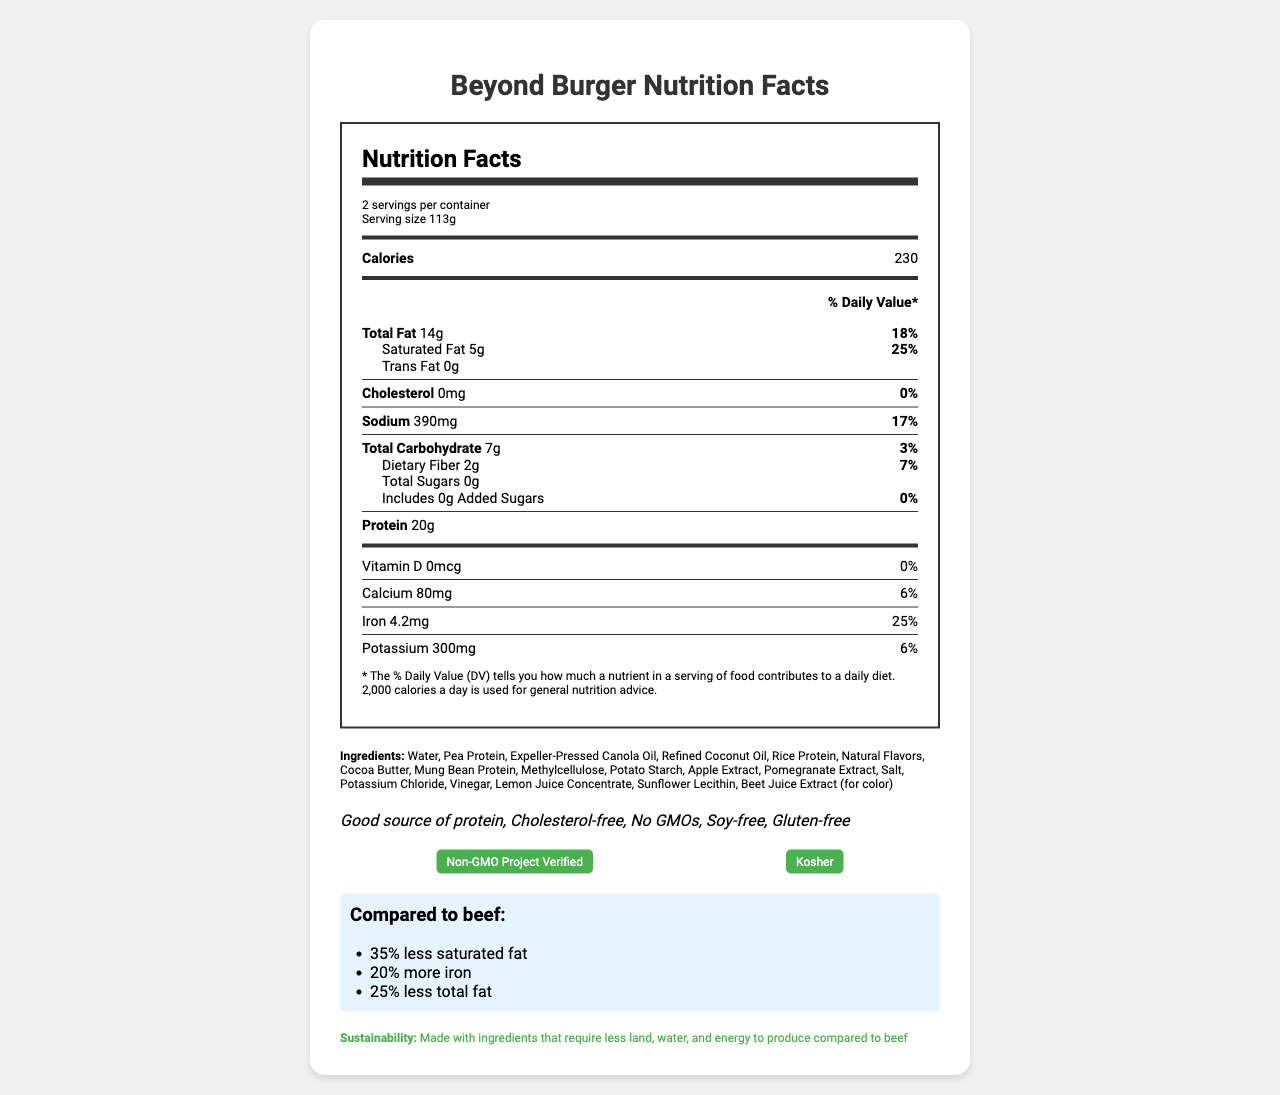How many servings are in a container of Beyond Burger? The label states "2 servings per container".
Answer: 2 What is the serving size of Beyond Burger? The label specifies the serving size as 113 grams.
Answer: 113g What is the total calorie count per serving for Beyond Burger? The label indicates that each serving contains 230 calories.
Answer: 230 calories How much protein is in each serving? The label lists that each serving has 20 grams of protein.
Answer: 20g How much total fat does one serving contain? The label mentions "Total Fat 14g".
Answer: 14g What percentage of daily value of iron does Beyond Burger provide? A. 10% B. 25% C. 50% The label indicates "Iron 25%".
Answer: B. 25% Which ingredient is used for coloring in Beyond Burger? A. Cocoa Butter B. Beet Juice Extract C. Sunflower Lecithin Beet Juice Extract is used for color, as listed in the ingredients.
Answer: B. Beet Juice Extract Is Beyond Burger gluten-free? The health claims mention that the product is gluten-free.
Answer: Yes Does Beyond Burger contain any cholesterol? The label states "Cholesterol 0mg" and "0% daily value".
Answer: No Summarize the nutritional benefits and characteristics of Beyond Burger. The product contains significant amounts of iron (25% DV) and calcium (6% DV), and it has a better nutritional profile compared to beef with less saturated and total fat.
Answer: Beyond Burger offers high protein content (20g per serving), no cholesterol, and is free from GMOs, soy, and gluten. It has eco-friendly packaging and is Non-GMO Project Verified and Kosher certified. Does Beyond Burger contain more or less iron compared to beef? The label indicates that Beyond Burger has 20% more iron compared to beef.
Answer: More Does Beyond Burger contain any added sugars? The label shows "Added Sugars 0g" and "0% daily value".
Answer: No What is the daily value percentage for saturated fat in one serving of Beyond Burger? The label indicates "Saturated Fat 25%".
Answer: 25% What certifications does Beyond Burger have? The label lists "Non-GMO Project Verified" and "Kosher" in the certifications section.
Answer: Non-GMO Project Verified, Kosher What is the shelf life of Beyond Burger? The document states the shelf life as "10 days refrigerated, 6 months frozen".
Answer: 10 days refrigerated, 6 months frozen How much calcium is in one serving of Beyond Burger? The label notes "Calcium 80mg".
Answer: 80mg Does Beyond Burger have GMO ingredients? The health claims mention "No GMOs".
Answer: No What are the main ingredients used in Beyond Burger? The ingredients list on the label provides a comprehensive list.
Answer: Water, Pea Protein, Expeller-Pressed Canola Oil, Refined Coconut Oil, Rice Protein, Natural Flavors, Cocoa Butter, Mung Bean Protein, Methylcellulose, Potato Starch, Apple Extract, Pomegranate Extract, Salt, Potassium Chloride, Vinegar, Lemon Juice Concentrate, Sunflower Lecithin, Beet Juice Extract (for color) What is the recommended internal cooking temperature for Beyond Burger? The label instructs to "Cook thoroughly to an internal temperature of 165°F".
Answer: 165°F What is the potassium content per serving of Beyond Burger? A. 200mg B. 300mg C. 500mg The label specifies "Potassium 300mg".
Answer: B. 300mg What is the main idea of this document? The document highlights the product's characteristics, nutritional content, benefits, and sustainability aspects.
Answer: The document provides a detailed overview of Beyond Burger's nutritional facts, ingredients, health claims, certifications, cooking instructions, shelf life, and comparisons to beef. 